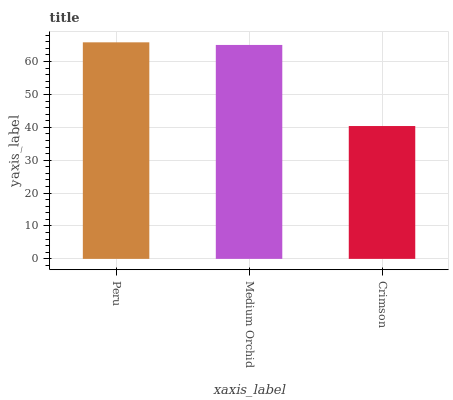Is Medium Orchid the minimum?
Answer yes or no. No. Is Medium Orchid the maximum?
Answer yes or no. No. Is Peru greater than Medium Orchid?
Answer yes or no. Yes. Is Medium Orchid less than Peru?
Answer yes or no. Yes. Is Medium Orchid greater than Peru?
Answer yes or no. No. Is Peru less than Medium Orchid?
Answer yes or no. No. Is Medium Orchid the high median?
Answer yes or no. Yes. Is Medium Orchid the low median?
Answer yes or no. Yes. Is Crimson the high median?
Answer yes or no. No. Is Crimson the low median?
Answer yes or no. No. 